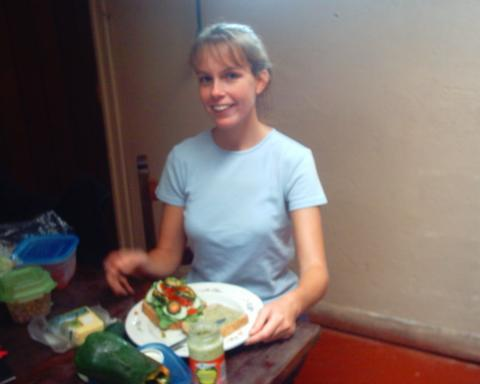What is this woman going to eat? sandwich 